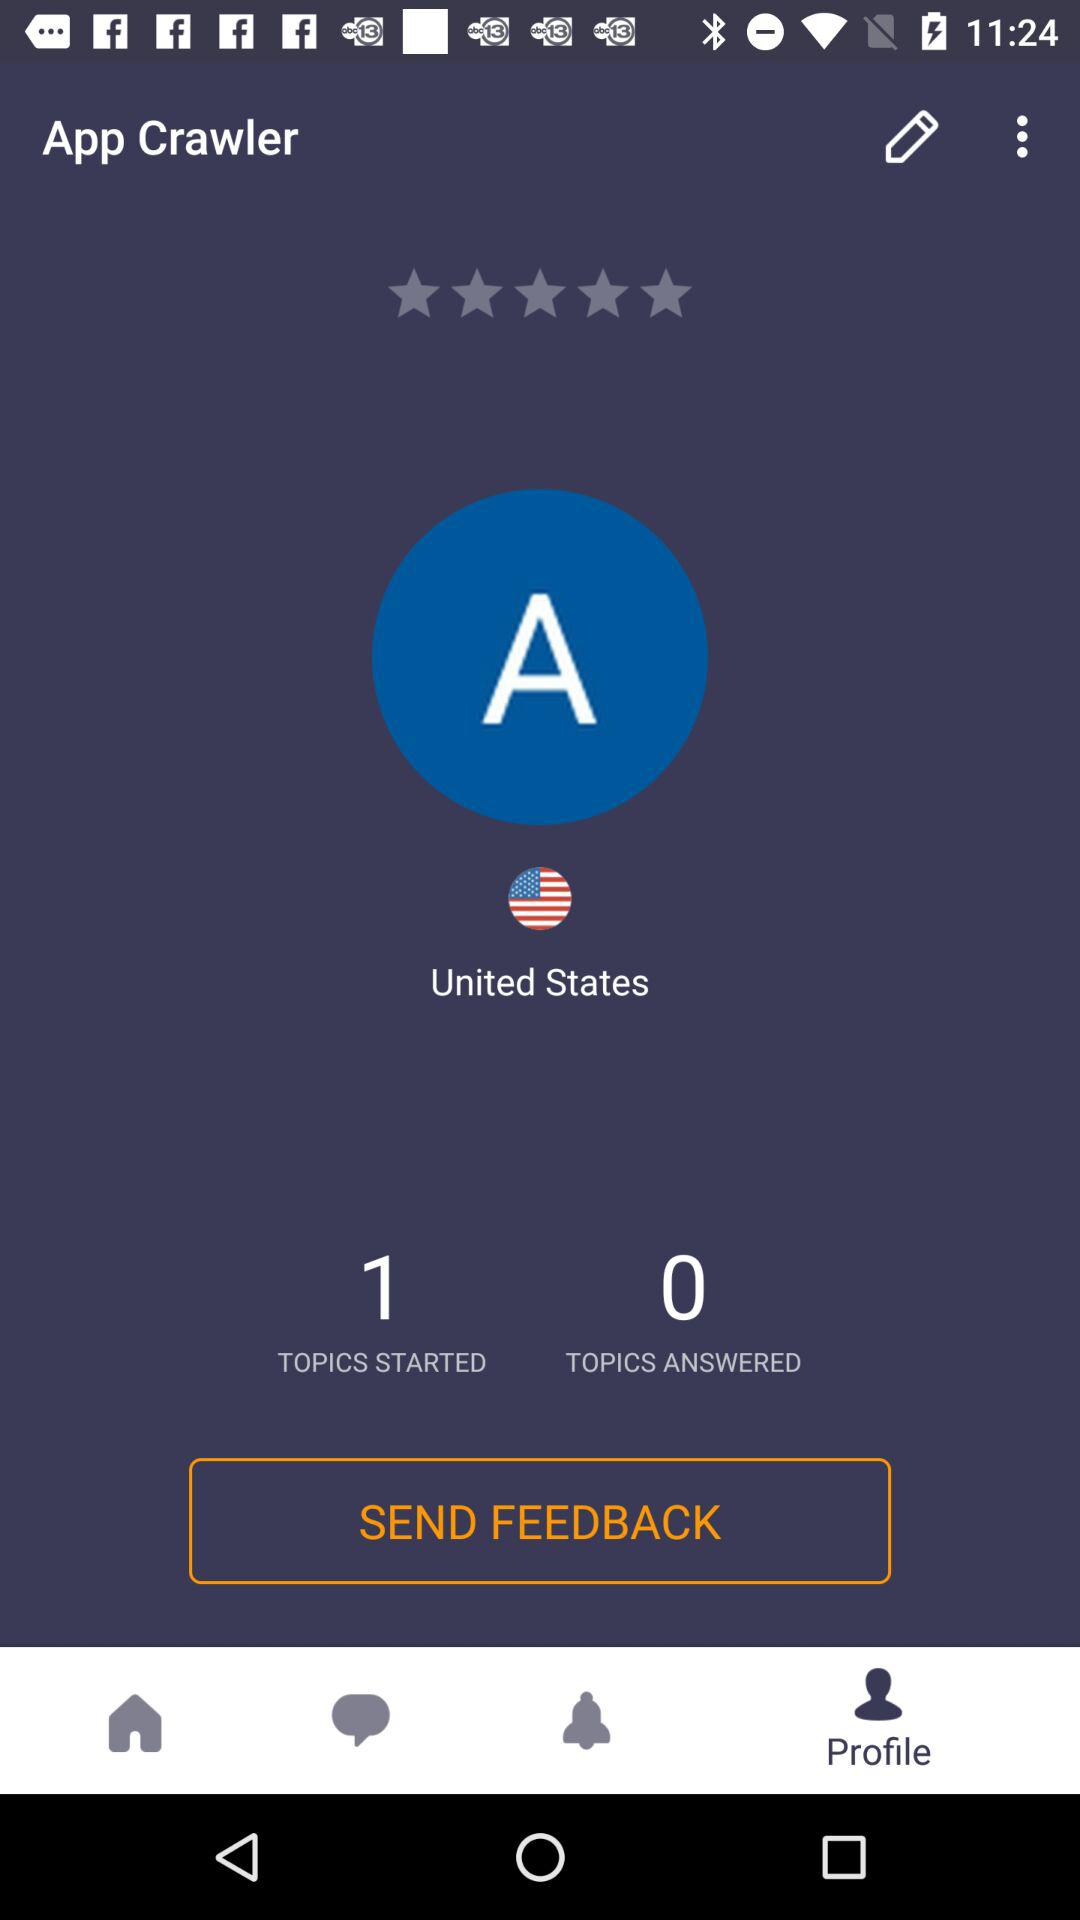How many more topics have been started than answered?
Answer the question using a single word or phrase. 1 